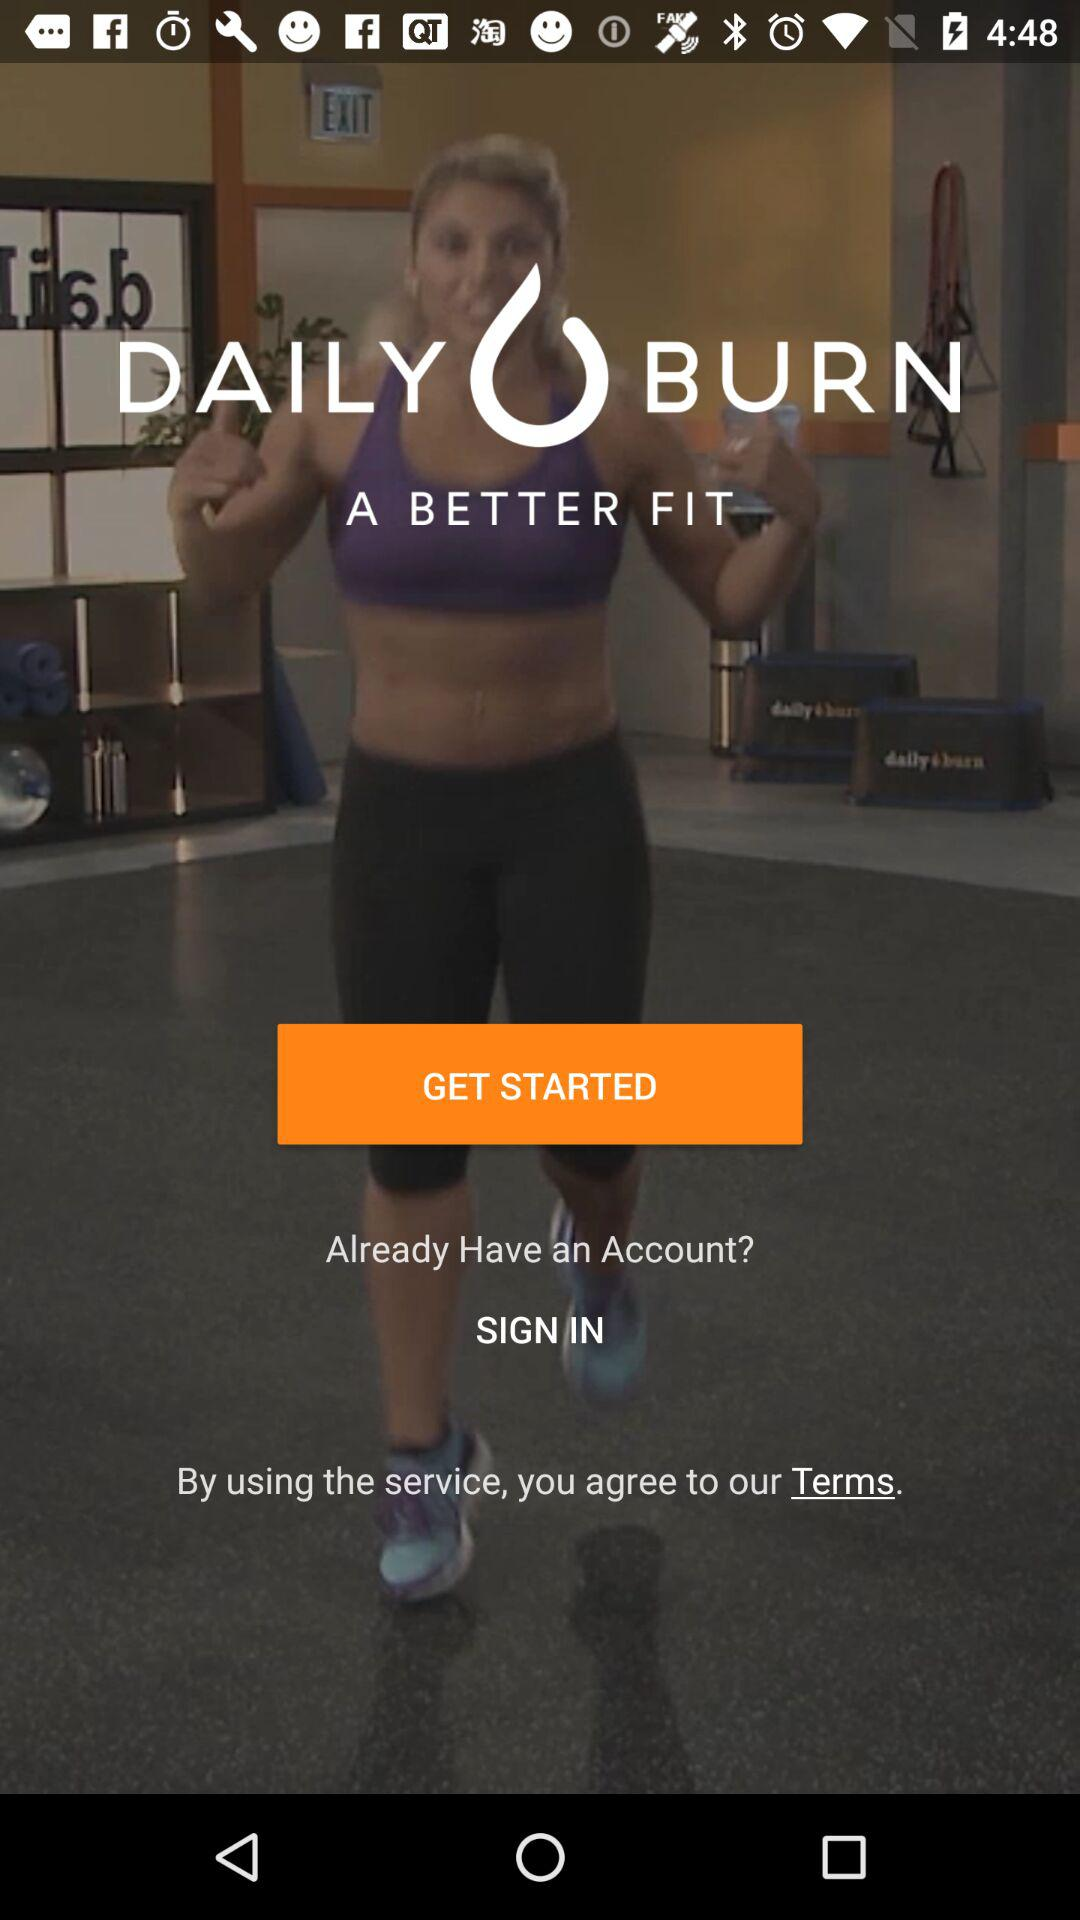How we can get started?
When the provided information is insufficient, respond with <no answer>. <no answer> 